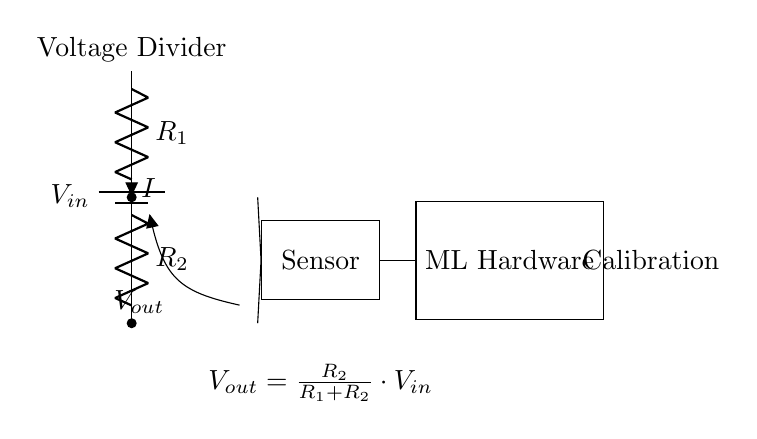What is the input voltage of the circuit? The input voltage is labeled as V in, which represents the voltage supplied to the circuit from the battery.
Answer: V in What are the two resistors in the circuit? The resistors in the circuit are R1 and R2, which are connected in series to create the voltage divider effect.
Answer: R1, R2 What is the output voltage formula given in the circuit? The output voltage formula provided is V out = (R2 / (R1 + R2)) * V in, indicating that the output voltage is a fraction of the input voltage based on the resistor values.
Answer: V out = R2/(R1 + R2) * V in What is the current flowing through the resistors? The current flowing through the resistors is denoted by I, indicating it is the same for both R1 and R2 since they are in series.
Answer: I How does this circuit relate to sensor calibration? The circuit provides V out to the sensor, allowing the sensor to be calibrated based on the adjusted output voltage from the voltage divider, which is crucial for accurate readings in machine learning applications.
Answer: Calibration What role does the ML hardware play in this circuit? The ML hardware receives the output from the sensor to process the calibrated readings for machine learning algorithms, which is essential for input training data.
Answer: Processing 